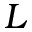Convert formula to latex. <formula><loc_0><loc_0><loc_500><loc_500>L</formula> 